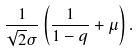<formula> <loc_0><loc_0><loc_500><loc_500>\frac { 1 } { \sqrt { 2 } \sigma } \left ( \frac { 1 } { 1 - q } + \mu \right ) .</formula> 